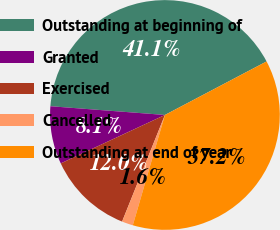<chart> <loc_0><loc_0><loc_500><loc_500><pie_chart><fcel>Outstanding at beginning of<fcel>Granted<fcel>Exercised<fcel>Cancelled<fcel>Outstanding at end of year<nl><fcel>41.07%<fcel>8.14%<fcel>11.99%<fcel>1.57%<fcel>37.22%<nl></chart> 